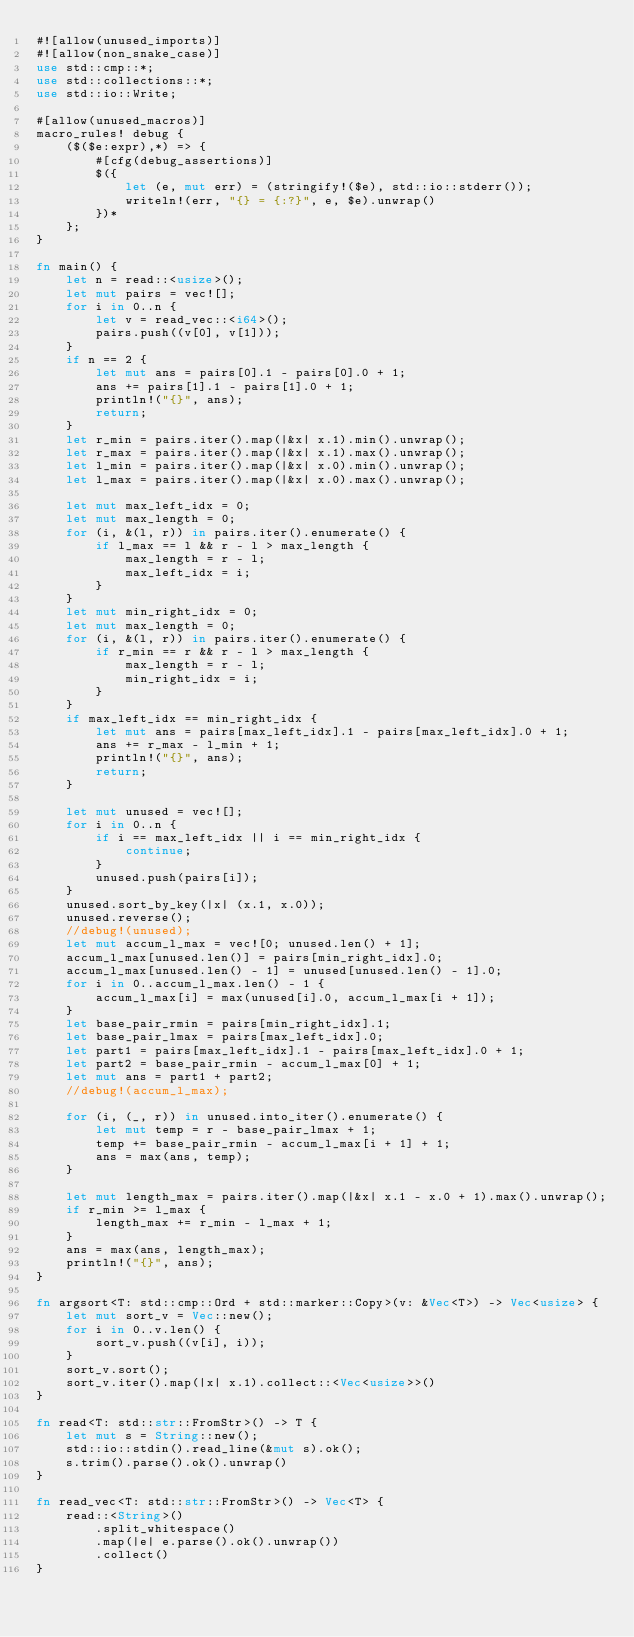<code> <loc_0><loc_0><loc_500><loc_500><_Rust_>#![allow(unused_imports)]
#![allow(non_snake_case)]
use std::cmp::*;
use std::collections::*;
use std::io::Write;

#[allow(unused_macros)]
macro_rules! debug {
    ($($e:expr),*) => {
        #[cfg(debug_assertions)]
        $({
            let (e, mut err) = (stringify!($e), std::io::stderr());
            writeln!(err, "{} = {:?}", e, $e).unwrap()
        })*
    };
}

fn main() {
    let n = read::<usize>();
    let mut pairs = vec![];
    for i in 0..n {
        let v = read_vec::<i64>();
        pairs.push((v[0], v[1]));
    }
    if n == 2 {
        let mut ans = pairs[0].1 - pairs[0].0 + 1;
        ans += pairs[1].1 - pairs[1].0 + 1;
        println!("{}", ans);
        return;
    }
    let r_min = pairs.iter().map(|&x| x.1).min().unwrap();
    let r_max = pairs.iter().map(|&x| x.1).max().unwrap();
    let l_min = pairs.iter().map(|&x| x.0).min().unwrap();
    let l_max = pairs.iter().map(|&x| x.0).max().unwrap();

    let mut max_left_idx = 0;
    let mut max_length = 0;
    for (i, &(l, r)) in pairs.iter().enumerate() {
        if l_max == l && r - l > max_length {
            max_length = r - l;
            max_left_idx = i;
        }
    }
    let mut min_right_idx = 0;
    let mut max_length = 0;
    for (i, &(l, r)) in pairs.iter().enumerate() {
        if r_min == r && r - l > max_length {
            max_length = r - l;
            min_right_idx = i;
        }
    }
    if max_left_idx == min_right_idx {
        let mut ans = pairs[max_left_idx].1 - pairs[max_left_idx].0 + 1;
        ans += r_max - l_min + 1;
        println!("{}", ans);
        return;
    }

    let mut unused = vec![];
    for i in 0..n {
        if i == max_left_idx || i == min_right_idx {
            continue;
        }
        unused.push(pairs[i]);
    }
    unused.sort_by_key(|x| (x.1, x.0));
    unused.reverse();
    //debug!(unused);
    let mut accum_l_max = vec![0; unused.len() + 1];
    accum_l_max[unused.len()] = pairs[min_right_idx].0;
    accum_l_max[unused.len() - 1] = unused[unused.len() - 1].0;
    for i in 0..accum_l_max.len() - 1 {
        accum_l_max[i] = max(unused[i].0, accum_l_max[i + 1]);
    }
    let base_pair_rmin = pairs[min_right_idx].1;
    let base_pair_lmax = pairs[max_left_idx].0;
    let part1 = pairs[max_left_idx].1 - pairs[max_left_idx].0 + 1;
    let part2 = base_pair_rmin - accum_l_max[0] + 1;
    let mut ans = part1 + part2;
    //debug!(accum_l_max);

    for (i, (_, r)) in unused.into_iter().enumerate() {
        let mut temp = r - base_pair_lmax + 1;
        temp += base_pair_rmin - accum_l_max[i + 1] + 1;
        ans = max(ans, temp);
    }

    let mut length_max = pairs.iter().map(|&x| x.1 - x.0 + 1).max().unwrap();
    if r_min >= l_max {
        length_max += r_min - l_max + 1;
    }
    ans = max(ans, length_max);
    println!("{}", ans);
}

fn argsort<T: std::cmp::Ord + std::marker::Copy>(v: &Vec<T>) -> Vec<usize> {
    let mut sort_v = Vec::new();
    for i in 0..v.len() {
        sort_v.push((v[i], i));
    }
    sort_v.sort();
    sort_v.iter().map(|x| x.1).collect::<Vec<usize>>()
}

fn read<T: std::str::FromStr>() -> T {
    let mut s = String::new();
    std::io::stdin().read_line(&mut s).ok();
    s.trim().parse().ok().unwrap()
}

fn read_vec<T: std::str::FromStr>() -> Vec<T> {
    read::<String>()
        .split_whitespace()
        .map(|e| e.parse().ok().unwrap())
        .collect()
}
</code> 